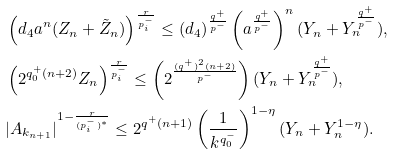<formula> <loc_0><loc_0><loc_500><loc_500>& \left ( d _ { 4 } a ^ { n } ( Z _ { n } + \tilde { Z } _ { n } ) \right ) ^ { \frac { r } { p ^ { - } _ { i } } } \leq \left ( d _ { 4 } \right ) ^ { \frac { q ^ { + } } { p ^ { - } } } \left ( a ^ { \frac { q ^ { + } } { p ^ { - } } } \right ) ^ { n } ( Y _ { n } + Y _ { n } ^ { \frac { q ^ { + } } { p ^ { - } } } ) , \\ & \left ( 2 ^ { q ^ { + } _ { 0 } ( n + 2 ) } Z _ { n } \right ) ^ { \frac { r } { p ^ { - } _ { i } } } \leq \left ( 2 ^ { \frac { ( q ^ { + } ) ^ { 2 } ( n + 2 ) } { p ^ { - } } } \right ) ( Y _ { n } + Y _ { n } ^ { \frac { q ^ { + } } { p ^ { - } } } ) , \\ & | A _ { k _ { n + 1 } } | ^ { 1 - \frac { r } { ( p ^ { - } _ { i } ) ^ { * } } } \leq 2 ^ { q ^ { + } ( n + 1 ) } \left ( \frac { 1 } { k ^ { q _ { 0 } ^ { - } } } \right ) ^ { 1 - \eta } ( Y _ { n } + Y _ { n } ^ { 1 - \eta } ) .</formula> 